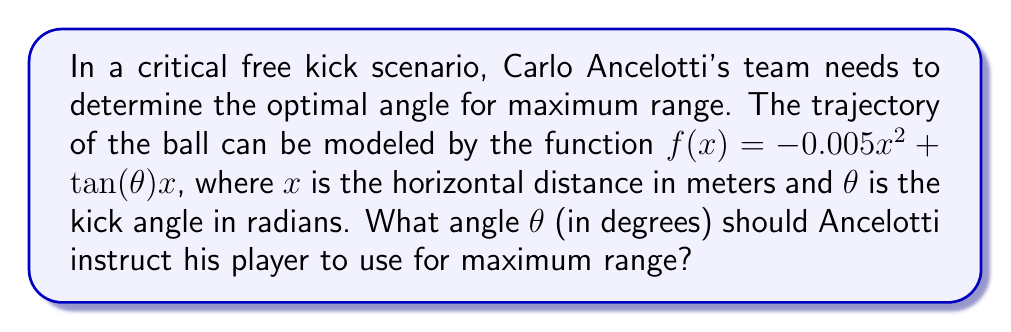Give your solution to this math problem. To find the optimal angle for maximum range, we need to follow these steps:

1) The range of the kick is determined by finding the x-intercept of the function. Set $f(x) = 0$:

   $0 = -0.005x^2 + \tan(\theta)x$

2) Solve for x:

   $x(0.005x - \tan(\theta)) = 0$
   $x = 0$ or $x = 200\tan(\theta)$

   The non-zero solution gives the range.

3) To maximize the range, we need to maximize $200\tan(\theta)$. Let's call this function $R(\theta)$:

   $R(\theta) = 200\tan(\theta)$

4) To find the maximum, we take the derivative and set it to zero:

   $R'(\theta) = 200\sec^2(\theta)$
   $200\sec^2(\theta) = 0$

5) However, $\sec^2(\theta)$ is always positive, so this equation has no solution. This means the maximum occurs at the endpoints of the domain.

6) The domain of $\tan(\theta)$ is $(-\frac{\pi}{2}, \frac{\pi}{2})$. As $\theta$ approaches $\frac{\pi}{4}$ from either side, $\tan(\theta)$ approaches infinity.

7) Therefore, the maximum range occurs when $\theta = \frac{\pi}{4}$ or 45 degrees.
Answer: 45° 